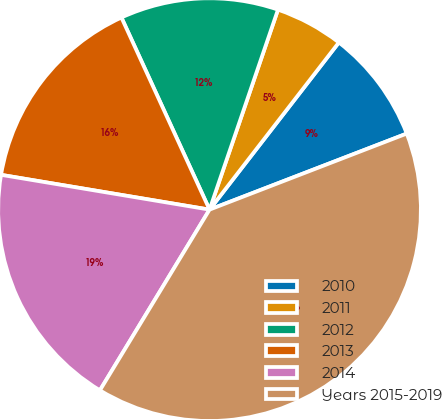Convert chart to OTSL. <chart><loc_0><loc_0><loc_500><loc_500><pie_chart><fcel>2010<fcel>2011<fcel>2012<fcel>2013<fcel>2014<fcel>Years 2015-2019<nl><fcel>8.66%<fcel>5.23%<fcel>12.09%<fcel>15.52%<fcel>18.95%<fcel>39.53%<nl></chart> 